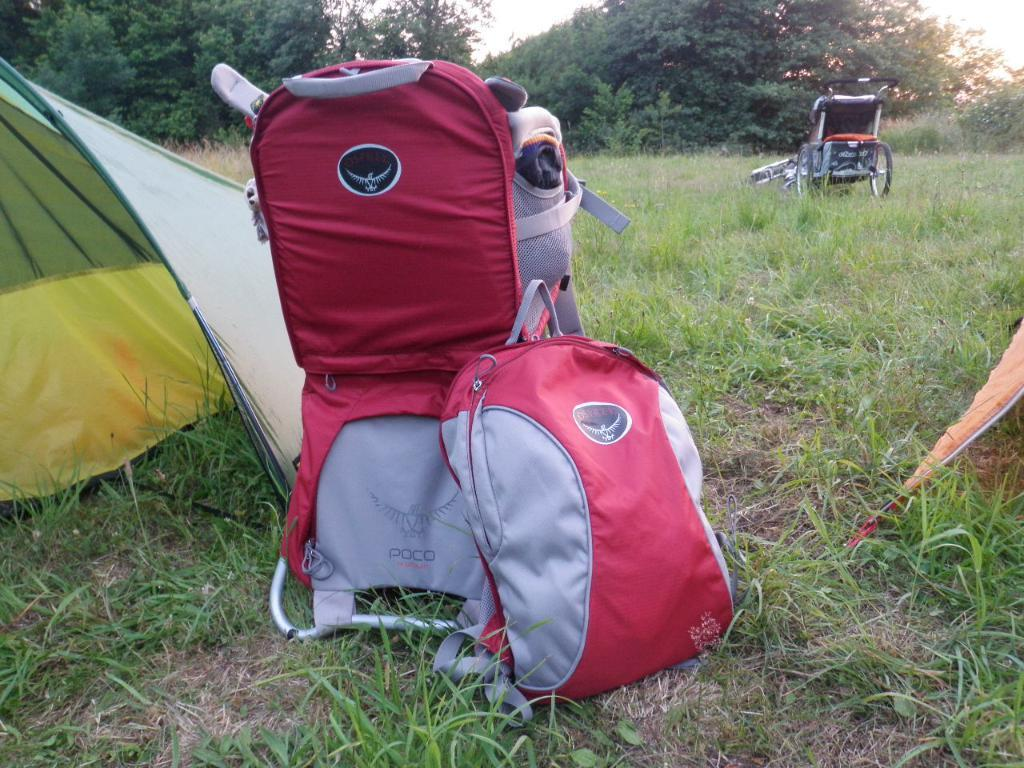What type of vegetation can be seen in the image? There is grass in the image. What else can be seen in the image besides grass? There are trees in the image. What is visible in the background of the image? The sky is visible in the image. What objects are on the ground in the image? There are bags on the ground in the image. What type of mobility aid is present in the image? There is a wheelchair in the image. What type of flock can be seen flying in the image? There is no flock of birds or animals visible in the image. What type of stove is present in the image? There is no stove present in the image. 